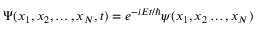Convert formula to latex. <formula><loc_0><loc_0><loc_500><loc_500>\Psi ( x _ { 1 } , x _ { 2 } , \dots , x _ { N } , t ) = e ^ { - i E t / } \psi ( x _ { 1 } , x _ { 2 } \dots , x _ { N } )</formula> 